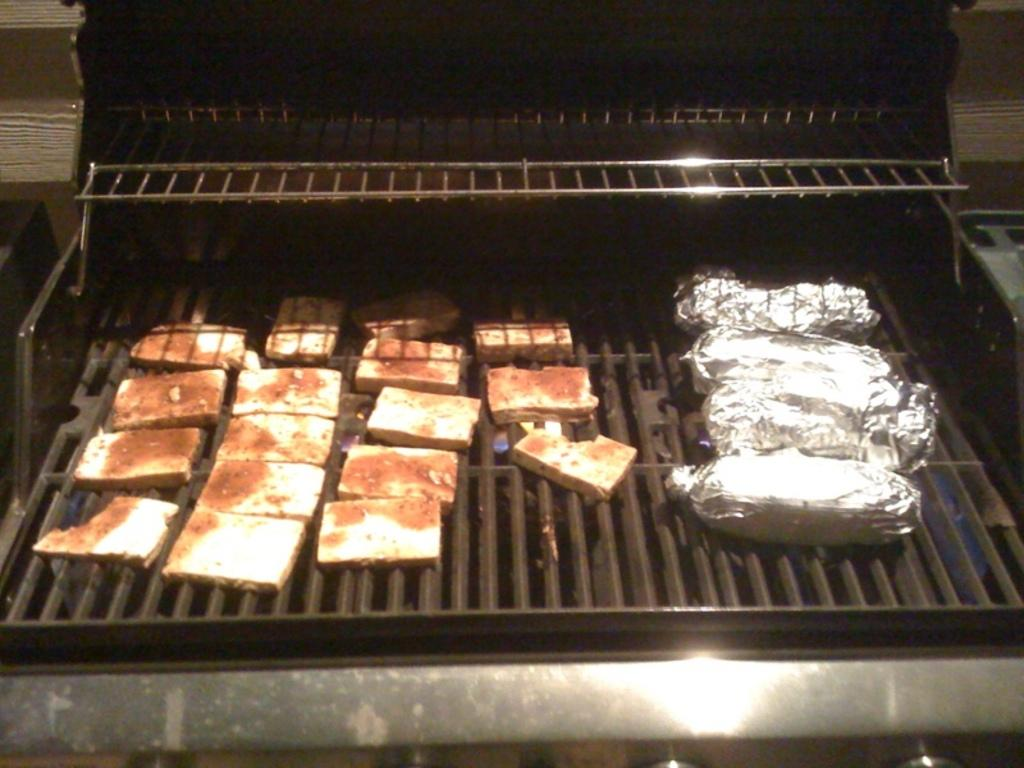What can be seen in the image that is used for cooking? There is a grill in the image that is used for cooking. What is on the grill in the image? There is food on the grill in the image. Can you describe a specific food item in the image? There is a food item with a silver wrapper in the image. What type of scarf is draped over the grill in the image? There is no scarf present in the image; it features a grill with food on it and a food item with a silver wrapper. 